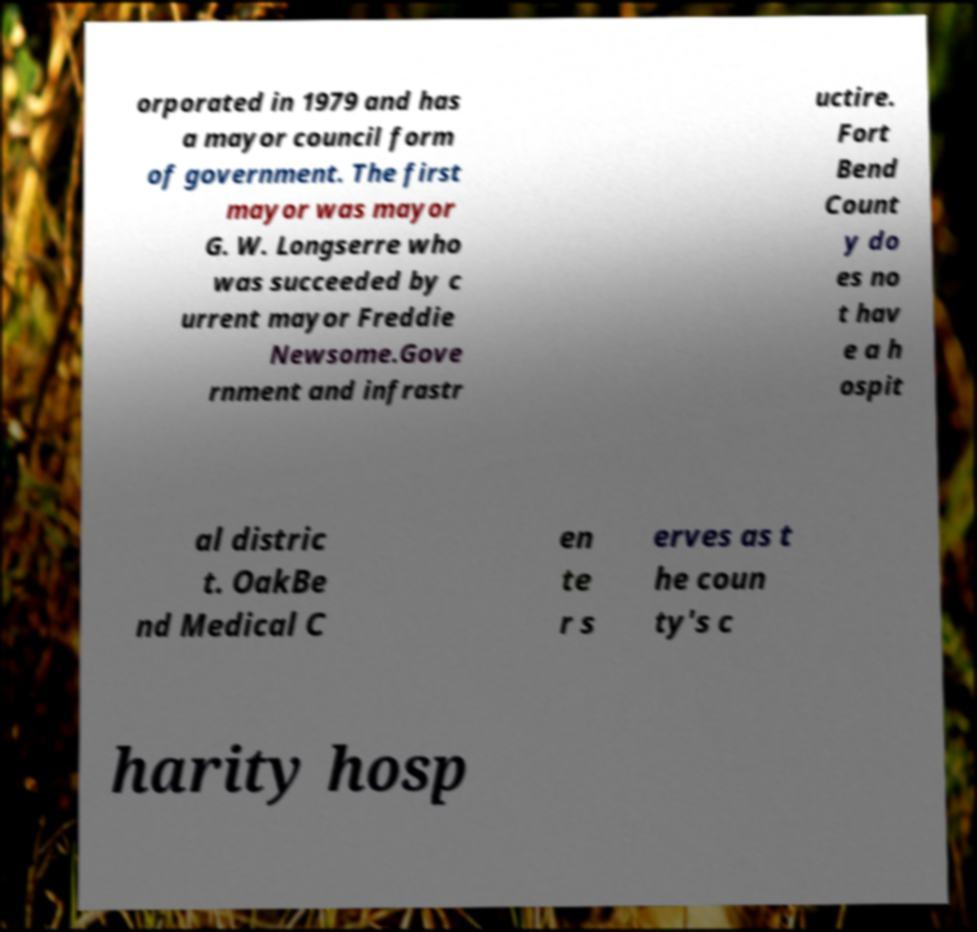Please identify and transcribe the text found in this image. orporated in 1979 and has a mayor council form of government. The first mayor was mayor G. W. Longserre who was succeeded by c urrent mayor Freddie Newsome.Gove rnment and infrastr uctire. Fort Bend Count y do es no t hav e a h ospit al distric t. OakBe nd Medical C en te r s erves as t he coun ty's c harity hosp 